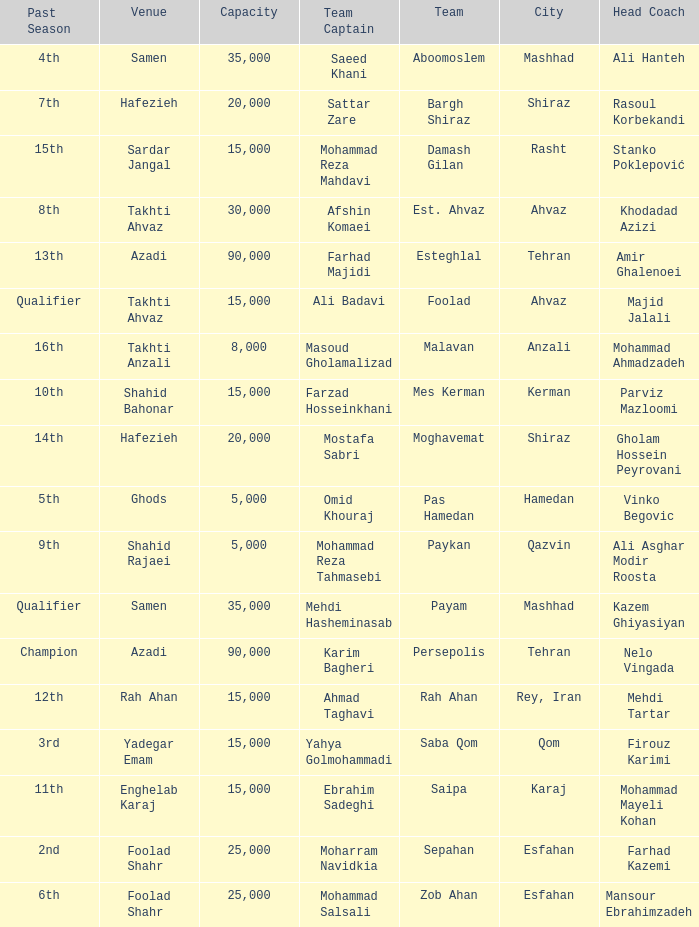What is the Capacity of the Venue of Head Coach Farhad Kazemi? 25000.0. 